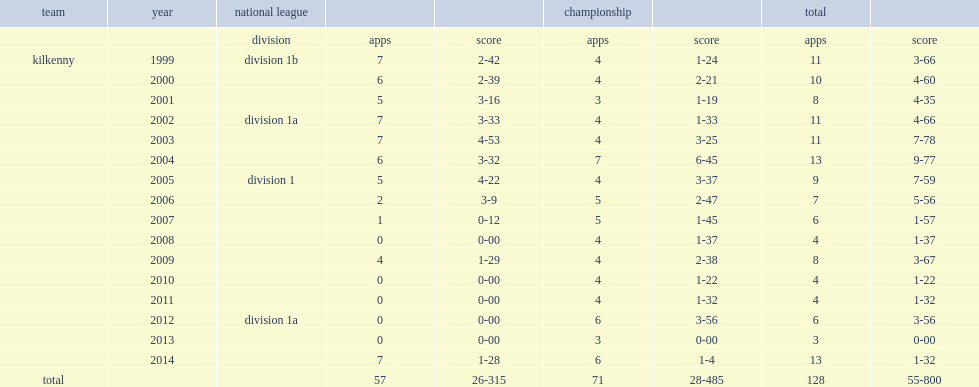What was the result(goals and points) did shefflin score totally? 28-485. 